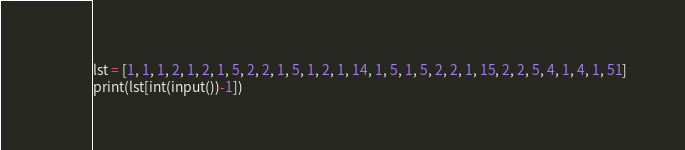Convert code to text. <code><loc_0><loc_0><loc_500><loc_500><_Python_>lst = [1, 1, 1, 2, 1, 2, 1, 5, 2, 2, 1, 5, 1, 2, 1, 14, 1, 5, 1, 5, 2, 2, 1, 15, 2, 2, 5, 4, 1, 4, 1, 51]
print(lst[int(input())-1])</code> 